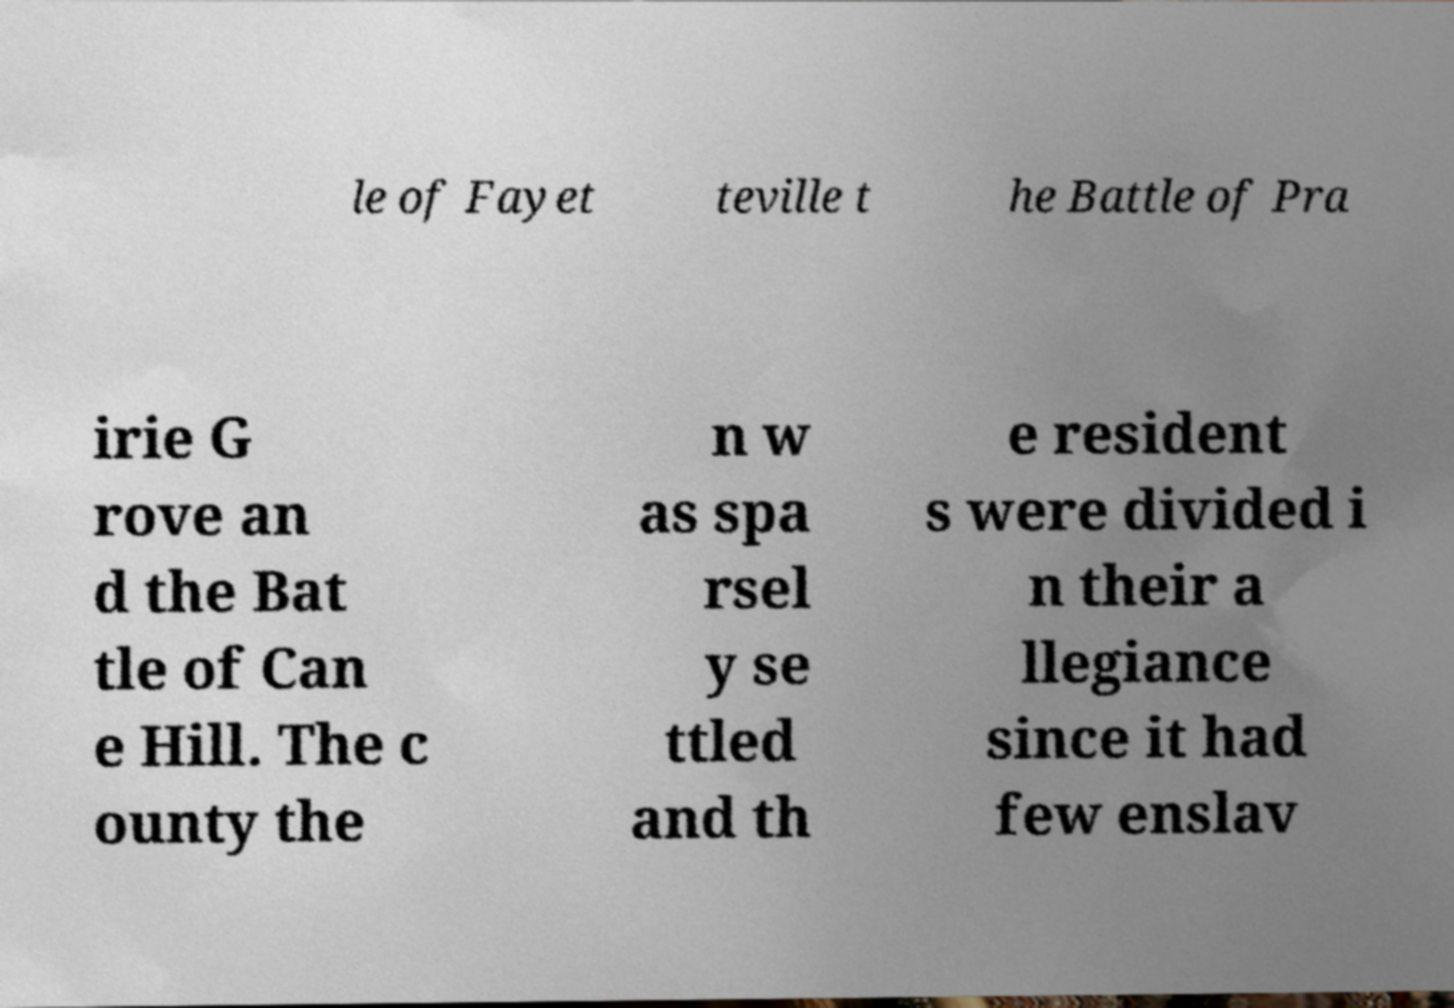Please identify and transcribe the text found in this image. le of Fayet teville t he Battle of Pra irie G rove an d the Bat tle of Can e Hill. The c ounty the n w as spa rsel y se ttled and th e resident s were divided i n their a llegiance since it had few enslav 